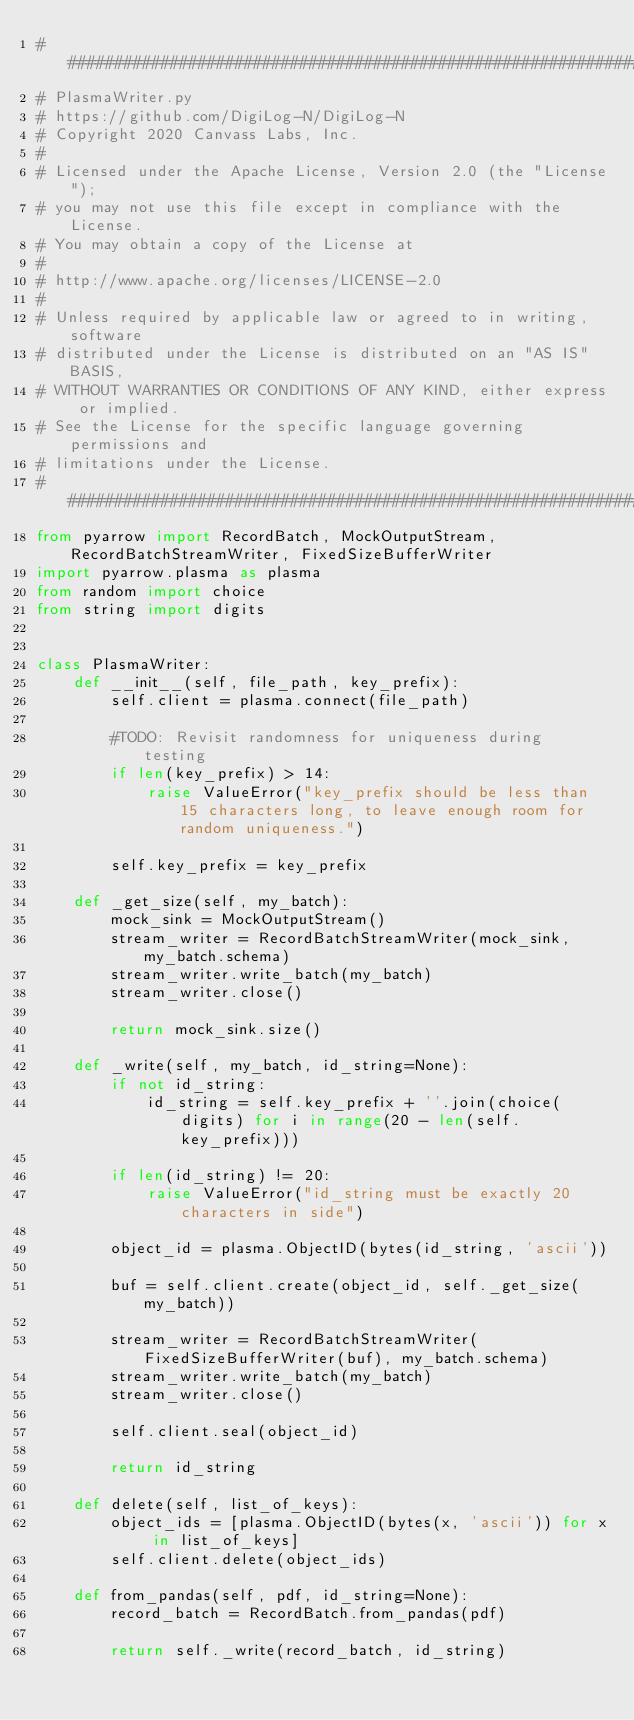Convert code to text. <code><loc_0><loc_0><loc_500><loc_500><_Python_>##############################################################################
# PlasmaWriter.py
# https://github.com/DigiLog-N/DigiLog-N
# Copyright 2020 Canvass Labs, Inc.
# 
# Licensed under the Apache License, Version 2.0 (the "License");
# you may not use this file except in compliance with the License.
# You may obtain a copy of the License at
# 
# http://www.apache.org/licenses/LICENSE-2.0
# 
# Unless required by applicable law or agreed to in writing, software
# distributed under the License is distributed on an "AS IS" BASIS,
# WITHOUT WARRANTIES OR CONDITIONS OF ANY KIND, either express or implied.
# See the License for the specific language governing permissions and
# limitations under the License.
##############################################################################
from pyarrow import RecordBatch, MockOutputStream, RecordBatchStreamWriter, FixedSizeBufferWriter
import pyarrow.plasma as plasma
from random import choice
from string import digits


class PlasmaWriter:
    def __init__(self, file_path, key_prefix):
        self.client = plasma.connect(file_path)

        #TODO: Revisit randomness for uniqueness during testing
        if len(key_prefix) > 14:
            raise ValueError("key_prefix should be less than 15 characters long, to leave enough room for random uniqueness.")

        self.key_prefix = key_prefix

    def _get_size(self, my_batch):
        mock_sink = MockOutputStream()
        stream_writer = RecordBatchStreamWriter(mock_sink, my_batch.schema)
        stream_writer.write_batch(my_batch)
        stream_writer.close()

        return mock_sink.size()

    def _write(self, my_batch, id_string=None):
        if not id_string:
            id_string = self.key_prefix + ''.join(choice(digits) for i in range(20 - len(self.key_prefix)))

        if len(id_string) != 20:
            raise ValueError("id_string must be exactly 20 characters in side")

        object_id = plasma.ObjectID(bytes(id_string, 'ascii'))

        buf = self.client.create(object_id, self._get_size(my_batch))

        stream_writer = RecordBatchStreamWriter(FixedSizeBufferWriter(buf), my_batch.schema)
        stream_writer.write_batch(my_batch)
        stream_writer.close()

        self.client.seal(object_id)

        return id_string

    def delete(self, list_of_keys):
        object_ids = [plasma.ObjectID(bytes(x, 'ascii')) for x in list_of_keys]
        self.client.delete(object_ids)

    def from_pandas(self, pdf, id_string=None):
        record_batch = RecordBatch.from_pandas(pdf)

        return self._write(record_batch, id_string)
</code> 